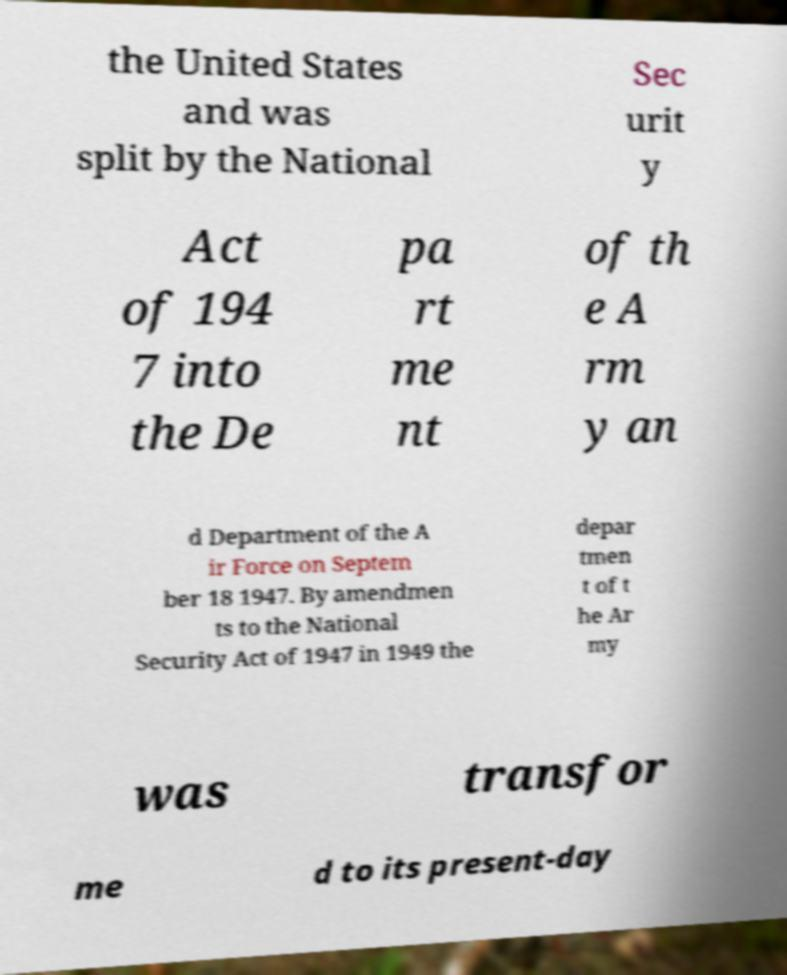Please identify and transcribe the text found in this image. the United States and was split by the National Sec urit y Act of 194 7 into the De pa rt me nt of th e A rm y an d Department of the A ir Force on Septem ber 18 1947. By amendmen ts to the National Security Act of 1947 in 1949 the depar tmen t of t he Ar my was transfor me d to its present-day 